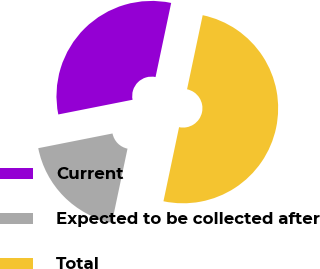<chart> <loc_0><loc_0><loc_500><loc_500><pie_chart><fcel>Current<fcel>Expected to be collected after<fcel>Total<nl><fcel>31.42%<fcel>18.58%<fcel>50.0%<nl></chart> 